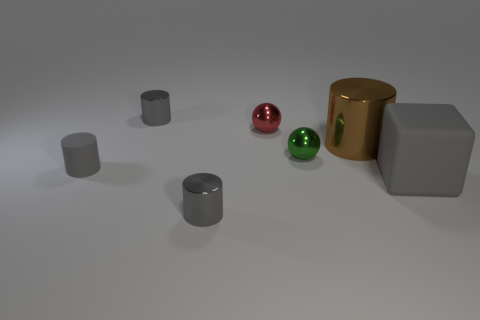Subtract all large cylinders. How many cylinders are left? 3 Subtract all gray cylinders. How many cylinders are left? 1 Add 1 small gray matte blocks. How many objects exist? 8 Subtract 1 blocks. How many blocks are left? 0 Subtract all green blocks. How many red spheres are left? 1 Subtract 1 green balls. How many objects are left? 6 Subtract all spheres. How many objects are left? 5 Subtract all cyan balls. Subtract all cyan cylinders. How many balls are left? 2 Subtract all small matte cylinders. Subtract all small yellow shiny blocks. How many objects are left? 6 Add 6 large brown shiny things. How many large brown shiny things are left? 7 